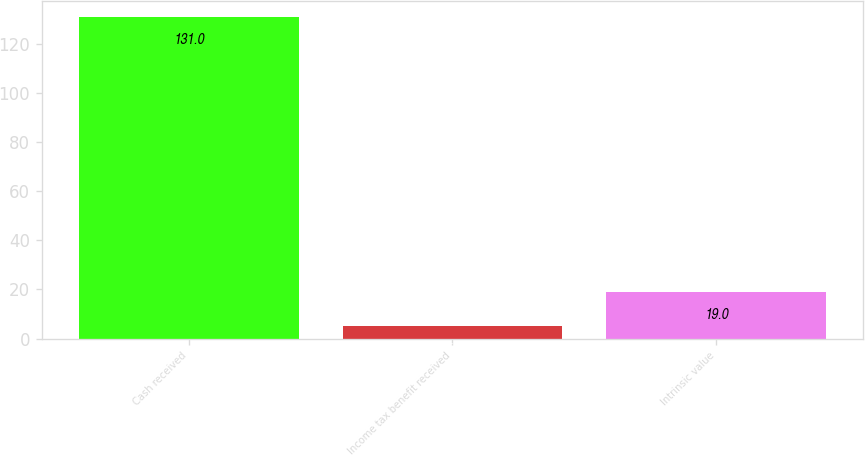Convert chart. <chart><loc_0><loc_0><loc_500><loc_500><bar_chart><fcel>Cash received<fcel>Income tax benefit received<fcel>Intrinsic value<nl><fcel>131<fcel>5<fcel>19<nl></chart> 